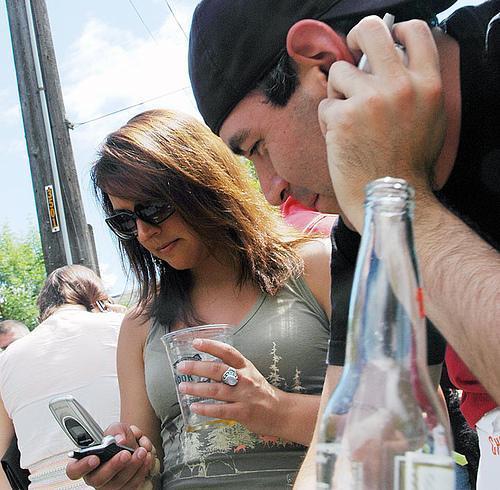How many bottles are in the photo?
Give a very brief answer. 1. How many people are visible?
Give a very brief answer. 3. How many cups can be seen?
Give a very brief answer. 1. 